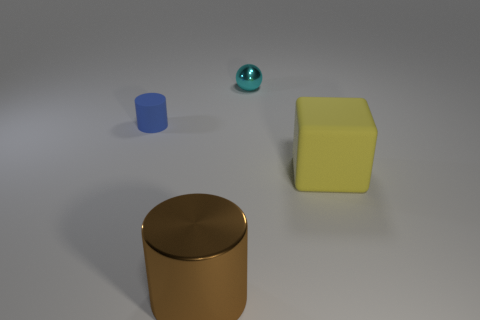Add 4 rubber cylinders. How many objects exist? 8 Subtract all blue cylinders. How many cylinders are left? 1 Subtract all cubes. How many objects are left? 3 Add 4 yellow matte objects. How many yellow matte objects exist? 5 Subtract 0 gray blocks. How many objects are left? 4 Subtract all blue metal things. Subtract all cyan metallic balls. How many objects are left? 3 Add 4 matte blocks. How many matte blocks are left? 5 